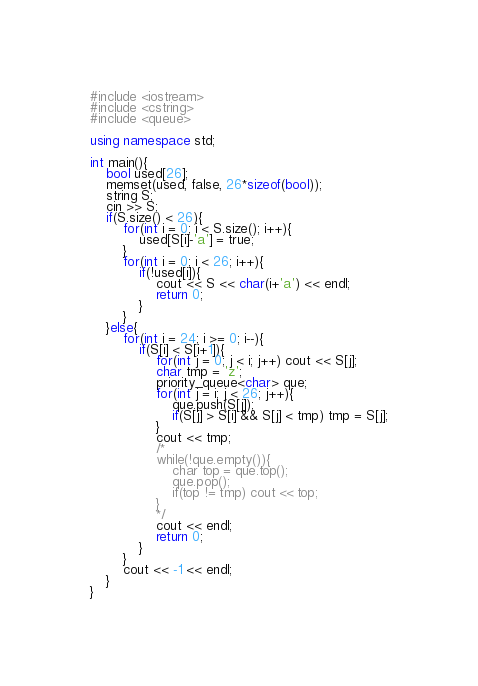<code> <loc_0><loc_0><loc_500><loc_500><_C++_>#include <iostream>
#include <cstring>
#include <queue>

using namespace std;

int main(){
    bool used[26];
    memset(used, false, 26*sizeof(bool));
    string S;
    cin >> S;
    if(S.size() < 26){
        for(int i = 0; i < S.size(); i++){
            used[S[i]-'a'] = true;
        }
        for(int i = 0; i < 26; i++){
            if(!used[i]){
                cout << S << char(i+'a') << endl;
                return 0;
            }
        }
    }else{
        for(int i = 24; i >= 0; i--){
            if(S[i] < S[i+1]){
                for(int j = 0; j < i; j++) cout << S[j];
                char tmp = 'z';
                priority_queue<char> que;
                for(int j = i; j < 26; j++){
                    que.push(S[j]);
                    if(S[j] > S[i] && S[j] < tmp) tmp = S[j];
                }
                cout << tmp;
                /*
                while(!que.empty()){
                    char top = que.top();
                    que.pop();
                    if(top != tmp) cout << top;
                }
                */
                cout << endl;
                return 0;
            }
        }
        cout << -1 << endl;
    }
}</code> 